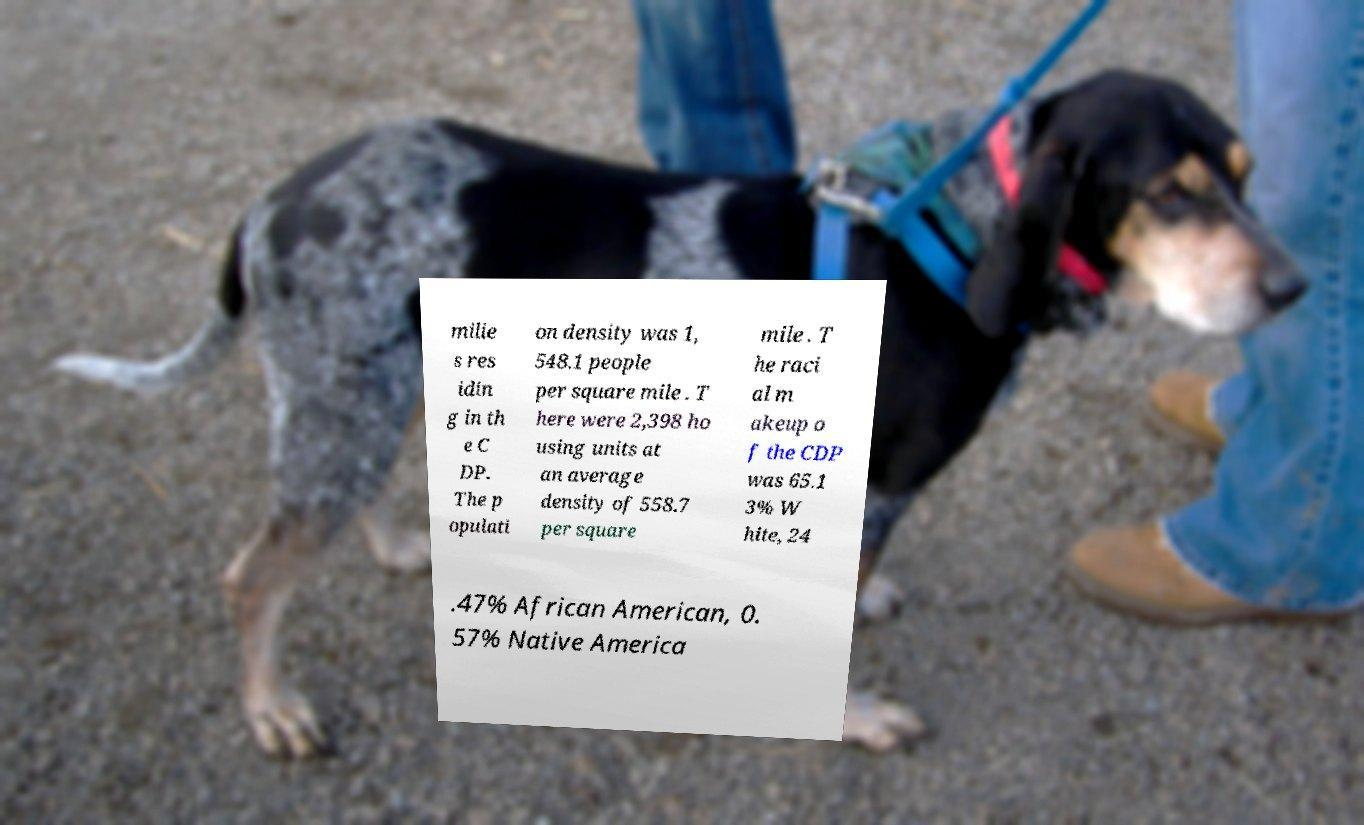Could you extract and type out the text from this image? milie s res idin g in th e C DP. The p opulati on density was 1, 548.1 people per square mile . T here were 2,398 ho using units at an average density of 558.7 per square mile . T he raci al m akeup o f the CDP was 65.1 3% W hite, 24 .47% African American, 0. 57% Native America 